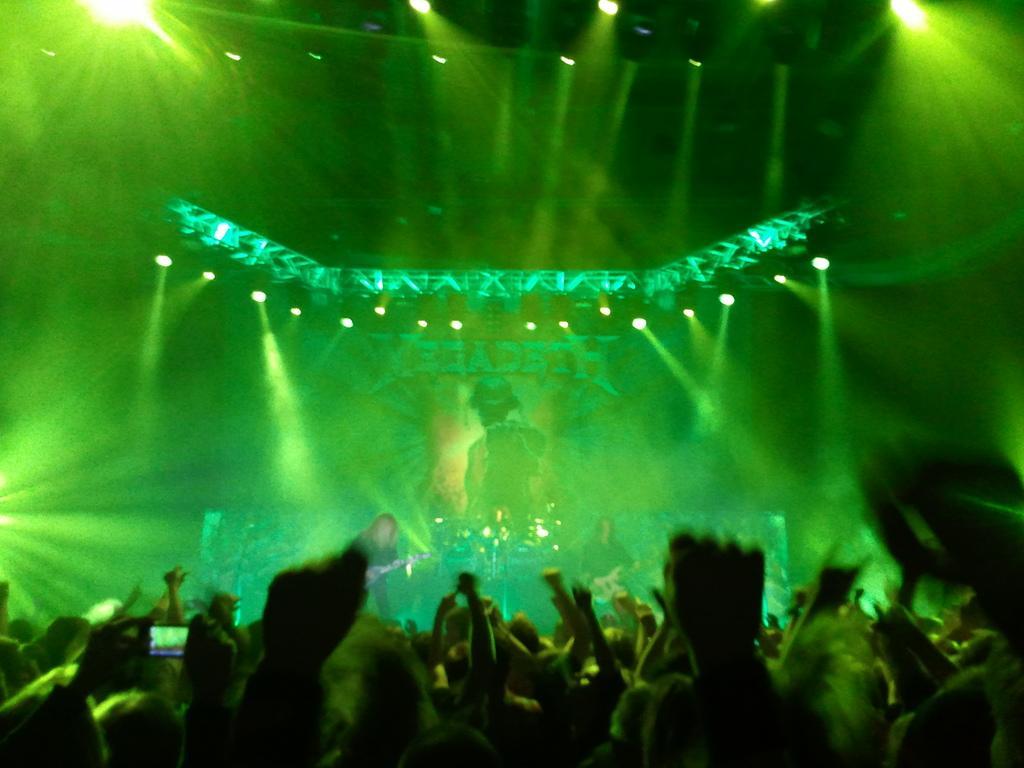In one or two sentences, can you explain what this image depicts? In this image there are few people dancing, in front of them there are two persons playing musical instruments. In the background there are few spot lights. 